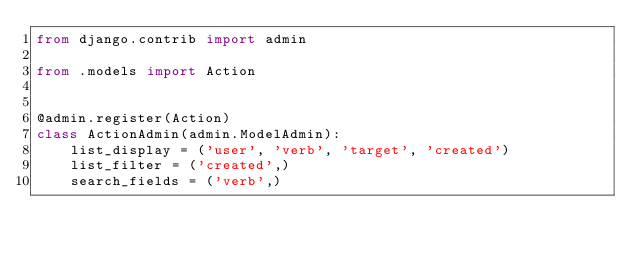Convert code to text. <code><loc_0><loc_0><loc_500><loc_500><_Python_>from django.contrib import admin

from .models import Action


@admin.register(Action)
class ActionAdmin(admin.ModelAdmin):
    list_display = ('user', 'verb', 'target', 'created')
    list_filter = ('created',)
    search_fields = ('verb',)</code> 